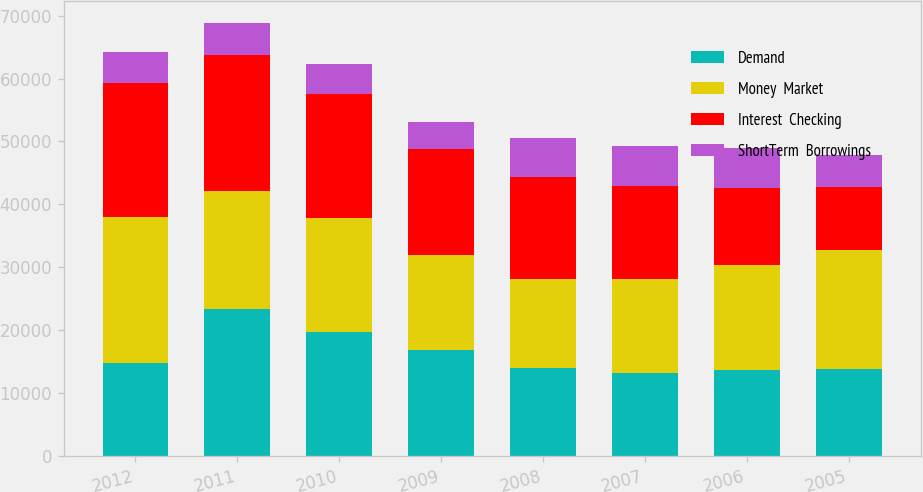Convert chart to OTSL. <chart><loc_0><loc_0><loc_500><loc_500><stacked_bar_chart><ecel><fcel>2012<fcel>2011<fcel>2010<fcel>2009<fcel>2008<fcel>2007<fcel>2006<fcel>2005<nl><fcel>Demand<fcel>14820<fcel>23389<fcel>19669<fcel>16862<fcel>14017<fcel>13261<fcel>13741<fcel>13868<nl><fcel>Money  Market<fcel>23096<fcel>18707<fcel>18218<fcel>15070<fcel>14191<fcel>14820<fcel>16650<fcel>18884<nl><fcel>Interest  Checking<fcel>21393<fcel>21652<fcel>19612<fcel>16875<fcel>16192<fcel>14836<fcel>12189<fcel>10007<nl><fcel>ShortTerm  Borrowings<fcel>4903<fcel>5154<fcel>4808<fcel>4320<fcel>6127<fcel>6308<fcel>6366<fcel>5170<nl></chart> 